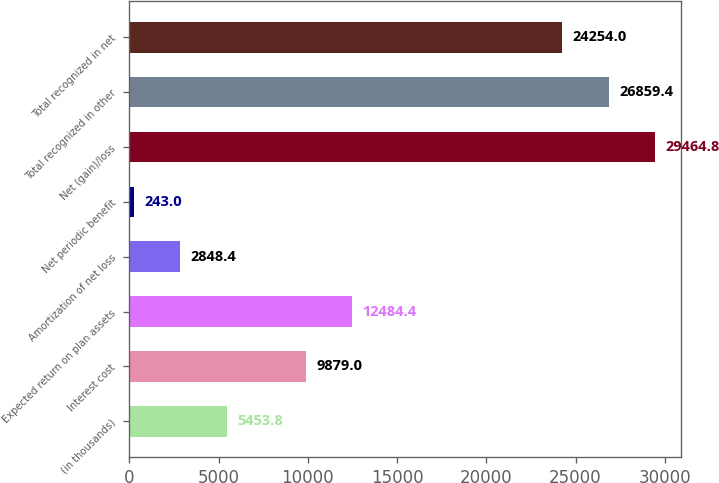<chart> <loc_0><loc_0><loc_500><loc_500><bar_chart><fcel>(in thousands)<fcel>Interest cost<fcel>Expected return on plan assets<fcel>Amortization of net loss<fcel>Net periodic benefit<fcel>Net (gain)/loss<fcel>Total recognized in other<fcel>Total recognized in net<nl><fcel>5453.8<fcel>9879<fcel>12484.4<fcel>2848.4<fcel>243<fcel>29464.8<fcel>26859.4<fcel>24254<nl></chart> 